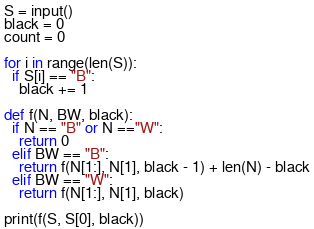Convert code to text. <code><loc_0><loc_0><loc_500><loc_500><_Python_>S = input()
black = 0
count = 0

for i in range(len(S)):
  if S[i] == "B":
    black += 1

def f(N, BW, black):
  if N == "B" or N =="W":
    return 0
  elif BW == "B":
    return f(N[1:], N[1], black - 1) + len(N) - black
  elif BW == "W":
    return f(N[1:], N[1], black)

print(f(S, S[0], black))</code> 